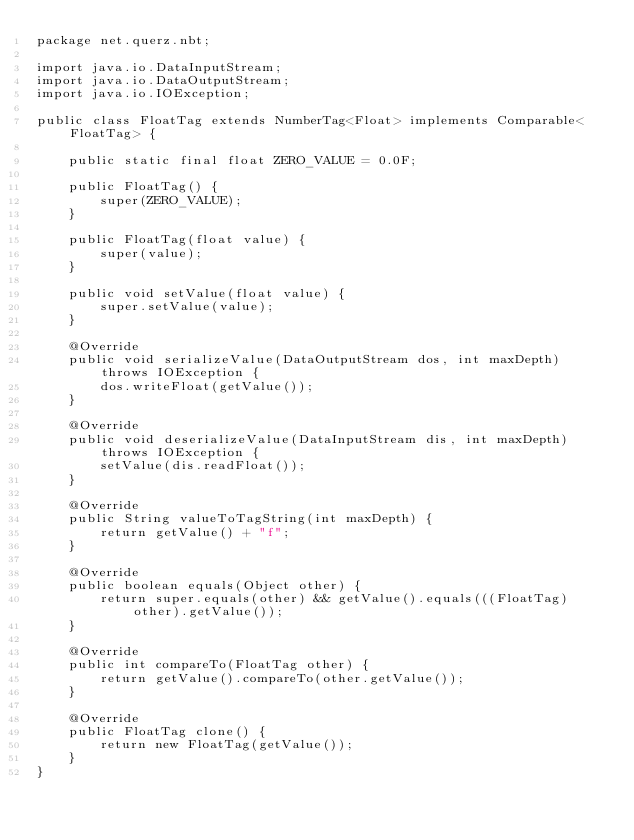<code> <loc_0><loc_0><loc_500><loc_500><_Java_>package net.querz.nbt;

import java.io.DataInputStream;
import java.io.DataOutputStream;
import java.io.IOException;

public class FloatTag extends NumberTag<Float> implements Comparable<FloatTag> {

	public static final float ZERO_VALUE = 0.0F;

	public FloatTag() {
		super(ZERO_VALUE);
	}

	public FloatTag(float value) {
		super(value);
	}

	public void setValue(float value) {
		super.setValue(value);
	}

	@Override
	public void serializeValue(DataOutputStream dos, int maxDepth) throws IOException {
		dos.writeFloat(getValue());
	}

	@Override
	public void deserializeValue(DataInputStream dis, int maxDepth) throws IOException {
		setValue(dis.readFloat());
	}

	@Override
	public String valueToTagString(int maxDepth) {
		return getValue() + "f";
	}

	@Override
	public boolean equals(Object other) {
		return super.equals(other) && getValue().equals(((FloatTag) other).getValue());
	}

	@Override
	public int compareTo(FloatTag other) {
		return getValue().compareTo(other.getValue());
	}

	@Override
	public FloatTag clone() {
		return new FloatTag(getValue());
	}
}
</code> 